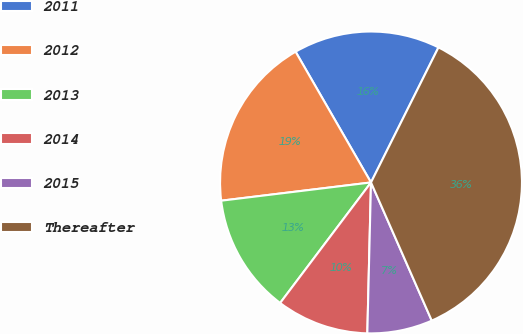Convert chart to OTSL. <chart><loc_0><loc_0><loc_500><loc_500><pie_chart><fcel>2011<fcel>2012<fcel>2013<fcel>2014<fcel>2015<fcel>Thereafter<nl><fcel>15.7%<fcel>18.6%<fcel>12.79%<fcel>9.89%<fcel>6.98%<fcel>36.03%<nl></chart> 